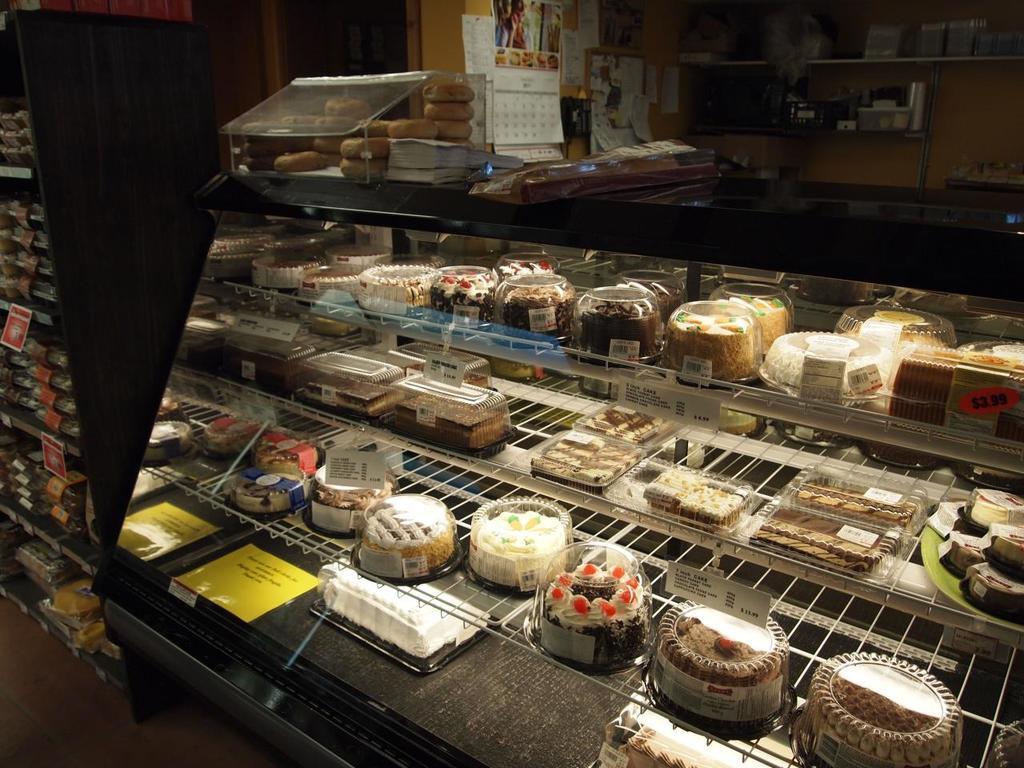Can you describe this image briefly? In this image there are cakes with the price tags and a few other items on the counter. Beside the counter there are a few food items on the wooden rack. Behind the counter. There is a calendar and there are papers on the wall. There are a few objects on the rack. 